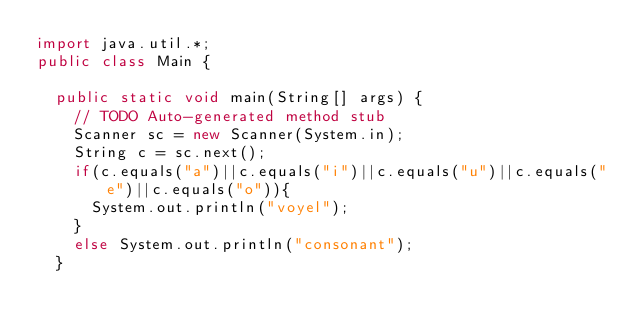<code> <loc_0><loc_0><loc_500><loc_500><_Java_>import java.util.*;
public class Main {

	public static void main(String[] args) {
		// TODO Auto-generated method stub
		Scanner sc = new Scanner(System.in);
		String c = sc.next();
		if(c.equals("a")||c.equals("i")||c.equals("u")||c.equals("e")||c.equals("o")){
			System.out.println("voyel");
		}
		else System.out.println("consonant");
	}
		
</code> 